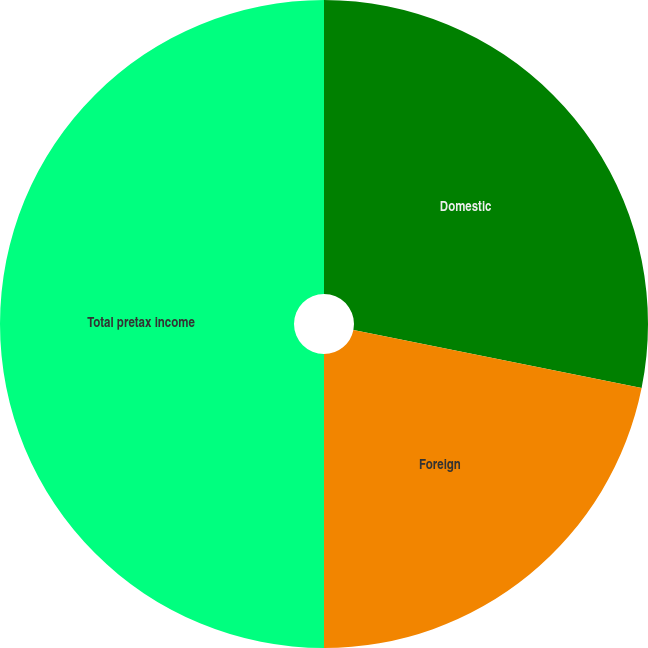<chart> <loc_0><loc_0><loc_500><loc_500><pie_chart><fcel>Domestic<fcel>Foreign<fcel>Total pretax income<nl><fcel>28.17%<fcel>21.83%<fcel>50.0%<nl></chart> 